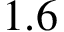Convert formula to latex. <formula><loc_0><loc_0><loc_500><loc_500>1 . 6</formula> 